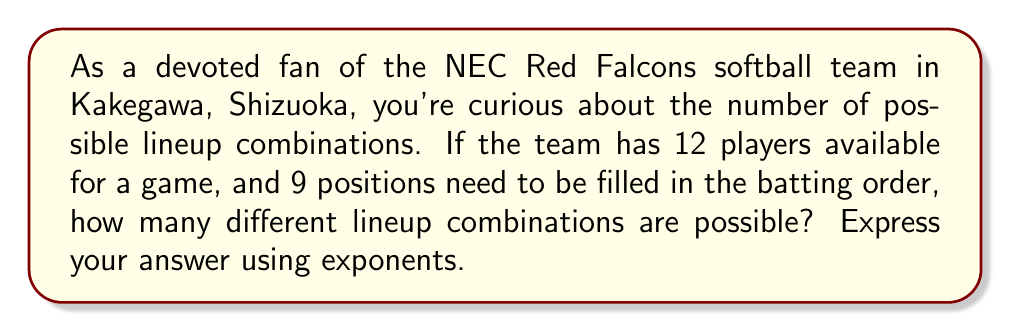Could you help me with this problem? To solve this problem, we need to use the concept of permutations. In this case, we are selecting 9 players out of 12 and arranging them in a specific order.

1) First, let's consider how many choices we have for each position:
   - For the 1st position: 12 choices
   - For the 2nd position: 11 choices (one player is already placed)
   - For the 3rd position: 10 choices
   ...and so on until the 9th position

2) The total number of combinations is the product of these choices:

   $12 \times 11 \times 10 \times 9 \times 8 \times 7 \times 6 \times 5 \times 4$

3) This can be written more concisely using factorial notation:

   $$\frac{12!}{(12-9)!} = \frac{12!}{3!}$$

4) However, the question asks for the answer in exponential form. We can express this as:

   $$12^9$$

5) This is because for each of the 9 positions, we are making a choice out of 12 players.

6) It's worth noting that $12^9$ slightly overestimates the actual number of combinations, as it allows for the same player to be chosen multiple times. The actual number (calculated using the factorial method) is 79,833,600, while $12^9 = 5,159,780,352$. However, $12^9$ is the closest exponential expression for this scenario.
Answer: $12^9$ 